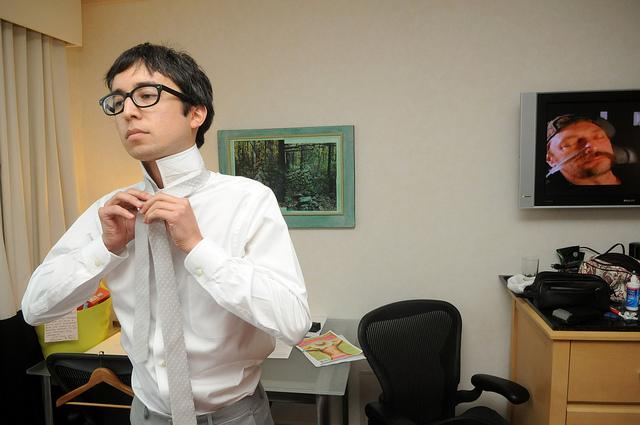What color theme is the man with the the tie trying to achieve with his outfit? Please explain your reasoning. grey. The tie is gray and the khakis are gray. 